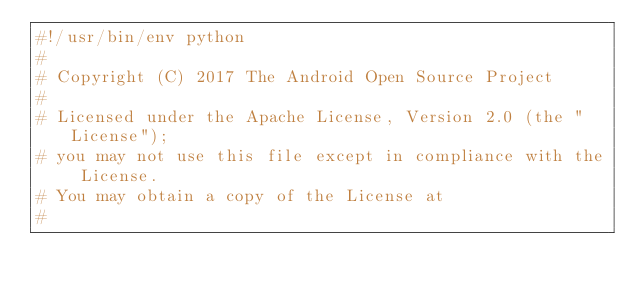Convert code to text. <code><loc_0><loc_0><loc_500><loc_500><_Python_>#!/usr/bin/env python
#
# Copyright (C) 2017 The Android Open Source Project
#
# Licensed under the Apache License, Version 2.0 (the "License");
# you may not use this file except in compliance with the License.
# You may obtain a copy of the License at
#</code> 